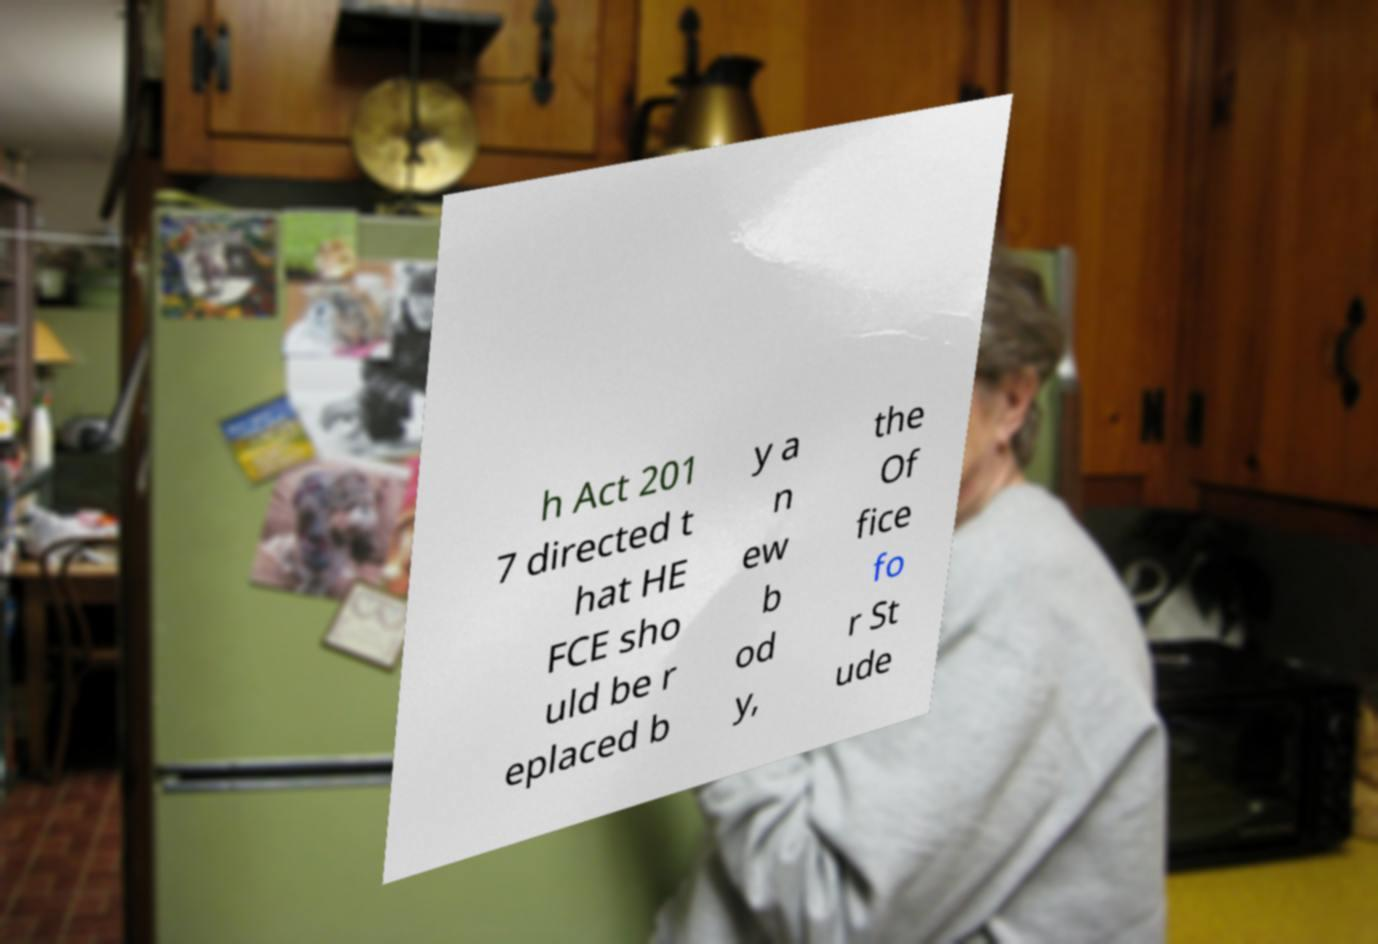Please identify and transcribe the text found in this image. h Act 201 7 directed t hat HE FCE sho uld be r eplaced b y a n ew b od y, the Of fice fo r St ude 